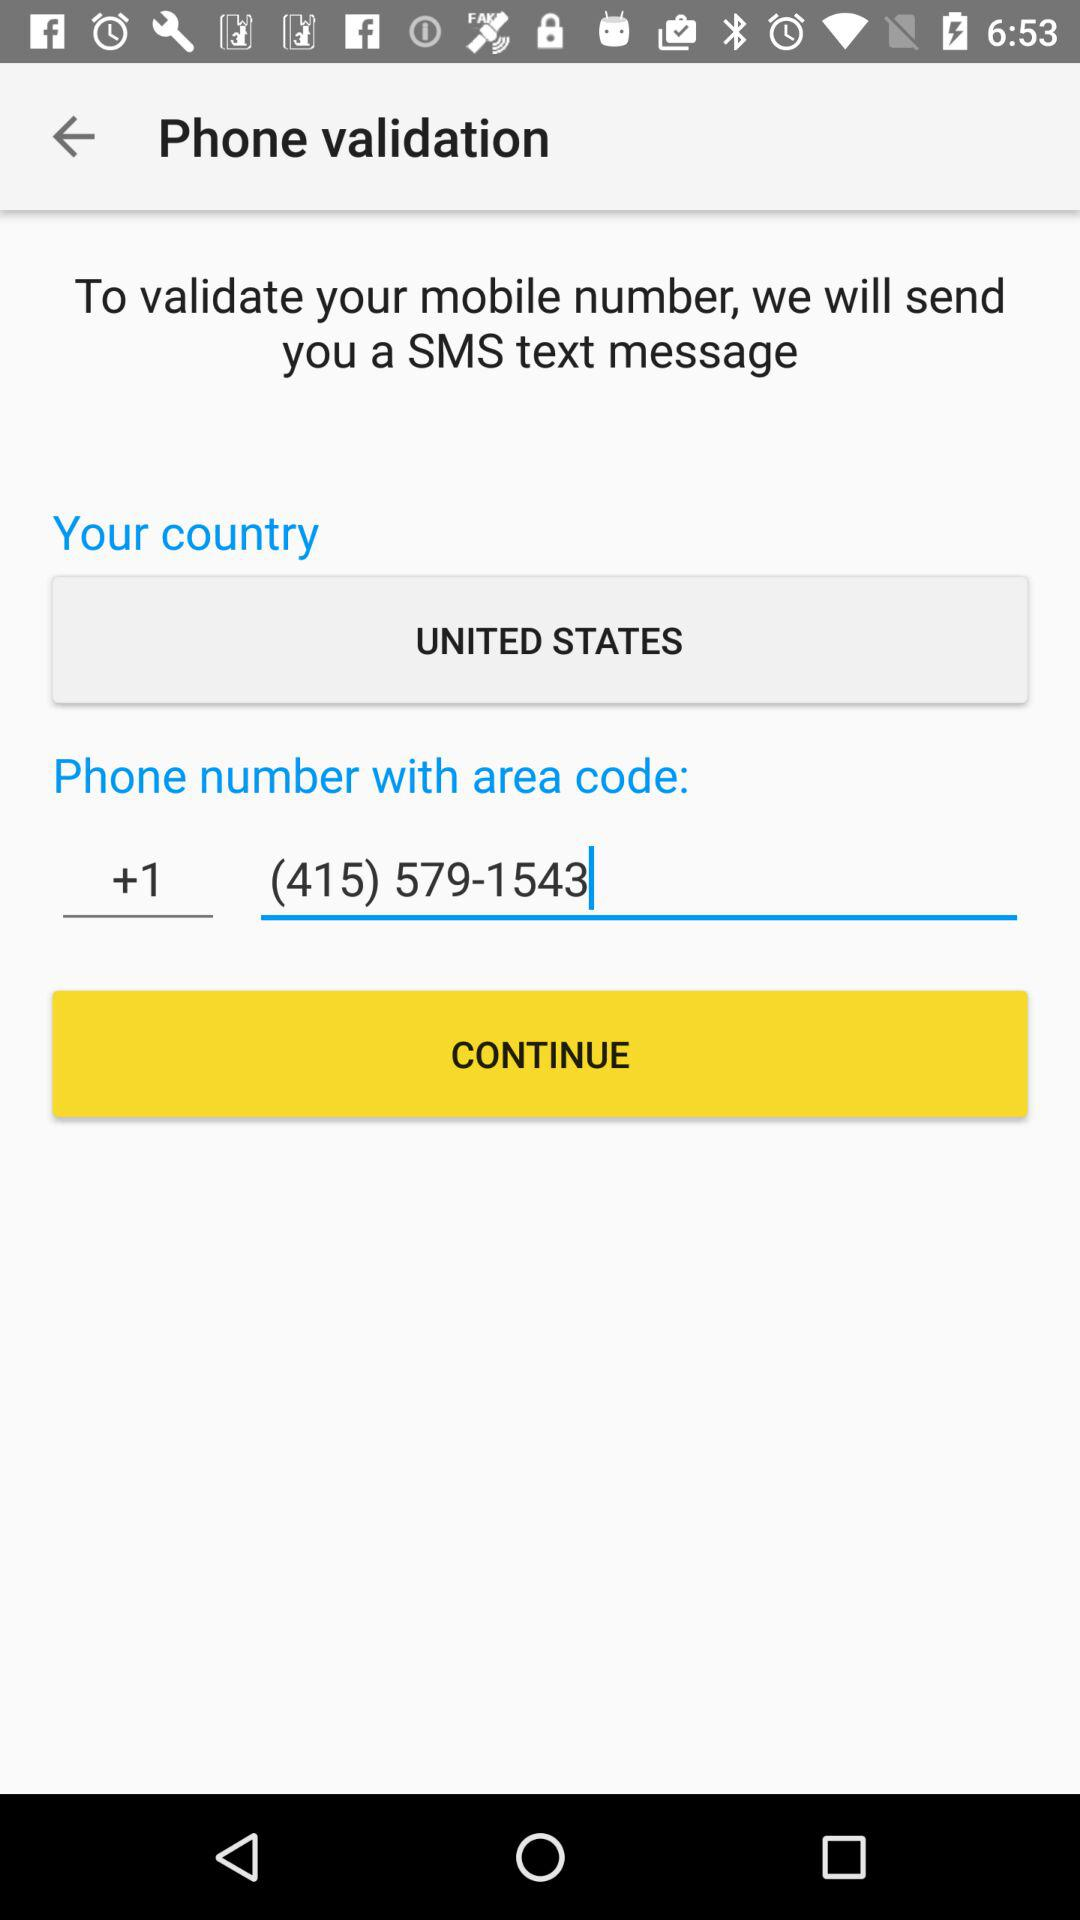What is the phone number? The phone number is (415) 579-1543. 